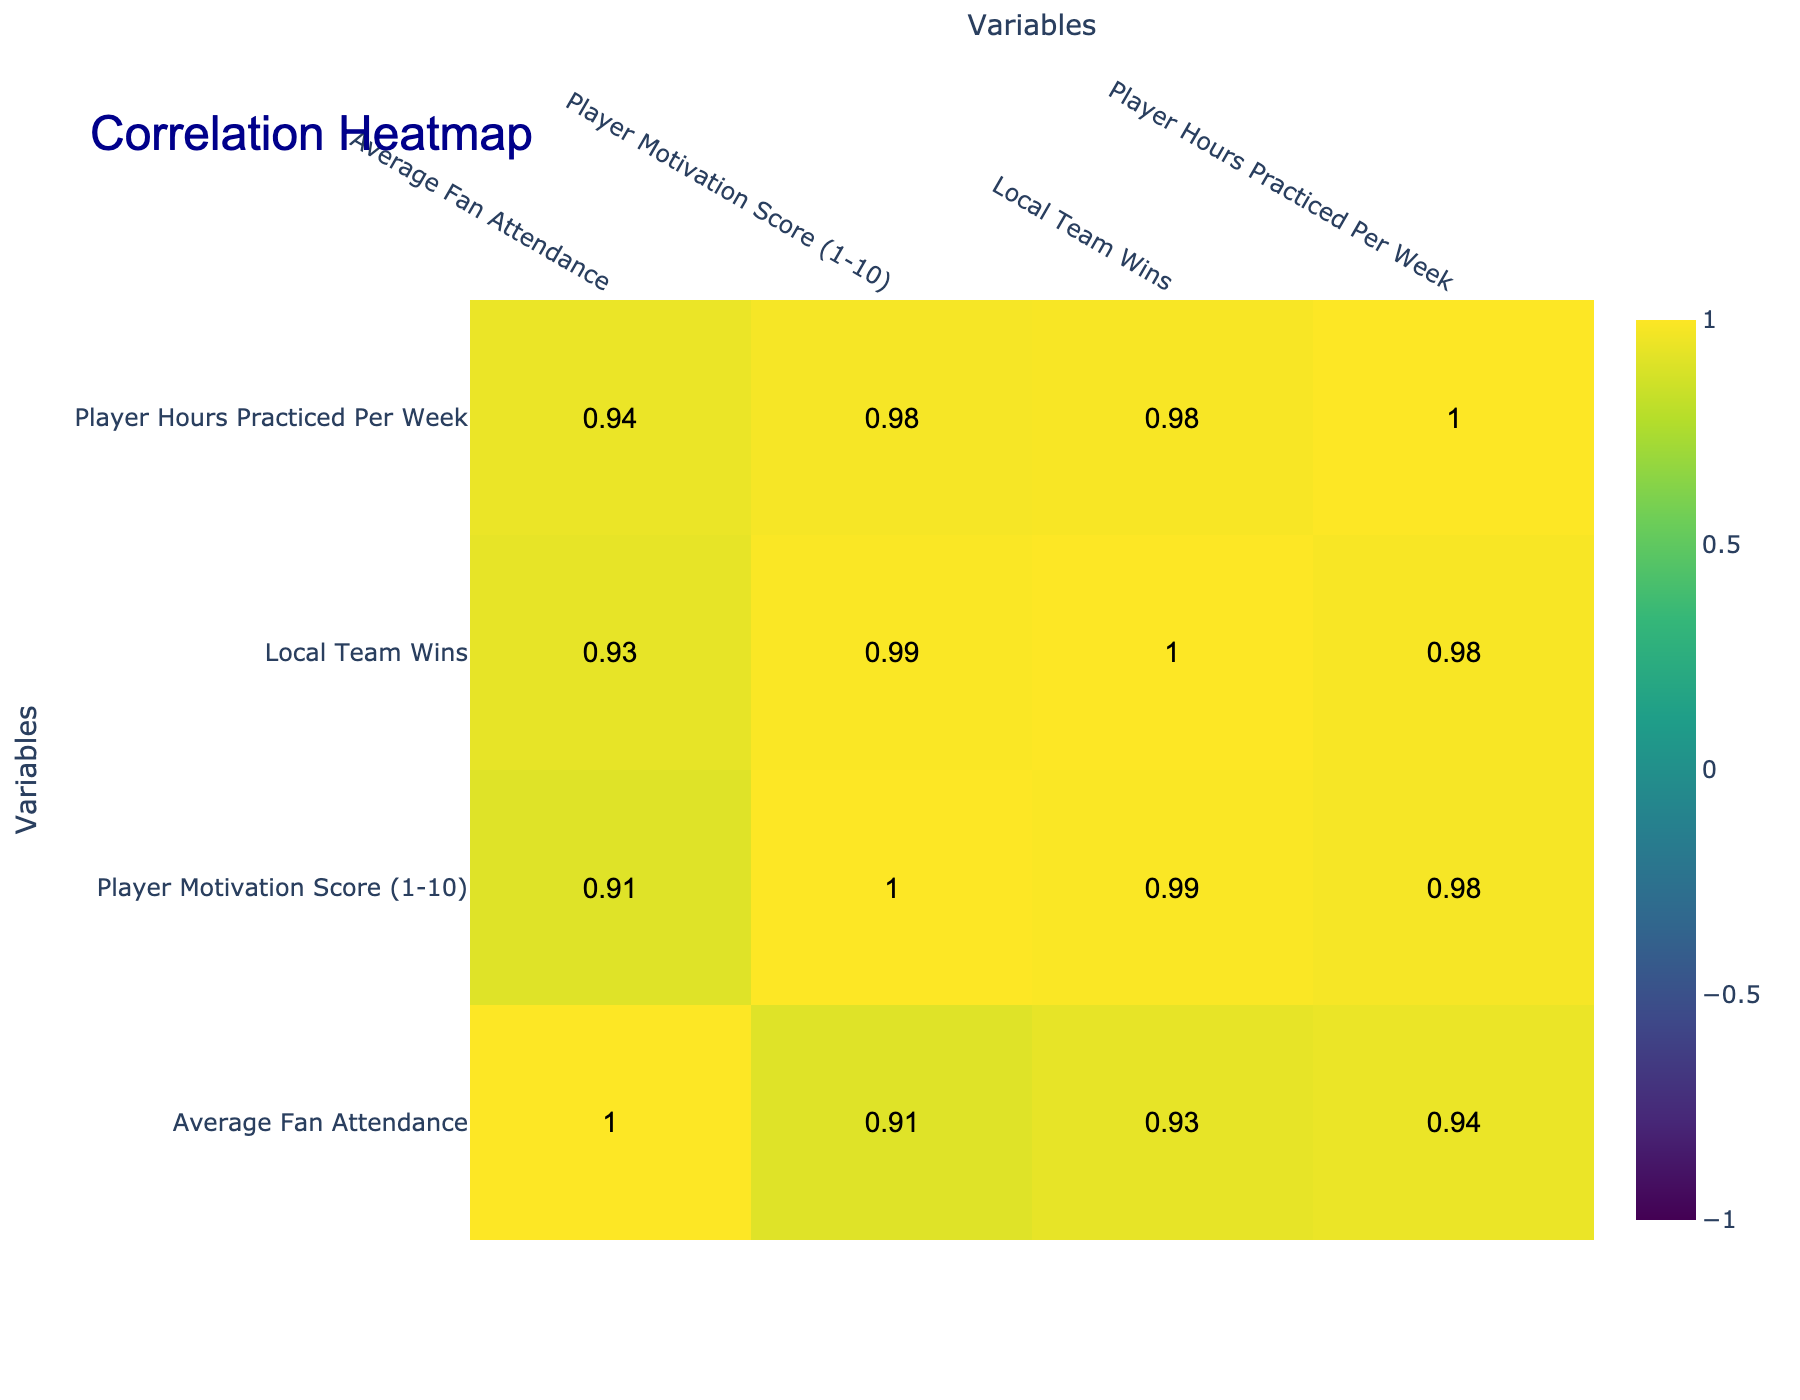What is the player motivation score for the Riverside Championship? According to the table, the Riverside Championship has a player motivation score of 10.
Answer: 10 Which tournament has the highest average fan attendance? The Riverside Championship has the highest average fan attendance of 250, according to the provided table.
Answer: 250 Is there a tournament where player motivation is 4? Yes, the Annual Block Party Tournament has a player motivation score of 4, as indicated in the table.
Answer: Yes What is the average player motivation score for tournaments with fan attendance over 150? The tournaments with fan attendance over 150 are the Riverside Championship (10), Neighborhood Showdown (8), City Park Open (9), and Downtown Summer League (8). Adding these scores gives 10 + 8 + 9 + 8 = 35. There are 4 tournaments, so the average is 35/4 = 8.75.
Answer: 8.75 Which tournament had the lowest local team wins? The Annual Block Party Tournament had the lowest local team wins, with a score of 1 as per the data provided.
Answer: 1 What is the correlation between average fan attendance and player motivation score? From the correlation table, the correlation between average fan attendance and player motivation score is likely to be high, as tournaments with higher attendance generally have higher player motivation scores, which suggests a positive relationship.
Answer: Positive correlation How does the player hours practiced per week vary among tournaments? The player hours practiced per week range from a minimum of 5 hours in the Annual Block Party Tournament to a maximum of 15 hours in the Riverside Championship, indicating that players in different tournaments vary their practice hours significantly.
Answer: 5 to 15 hours Are player motivation scores generally higher in tournaments with more fan attendance? Yes, the data suggests that tournaments with more fan attendance also have higher player motivation scores, reflecting that fan engagement positively impacts player performance.
Answer: Yes 